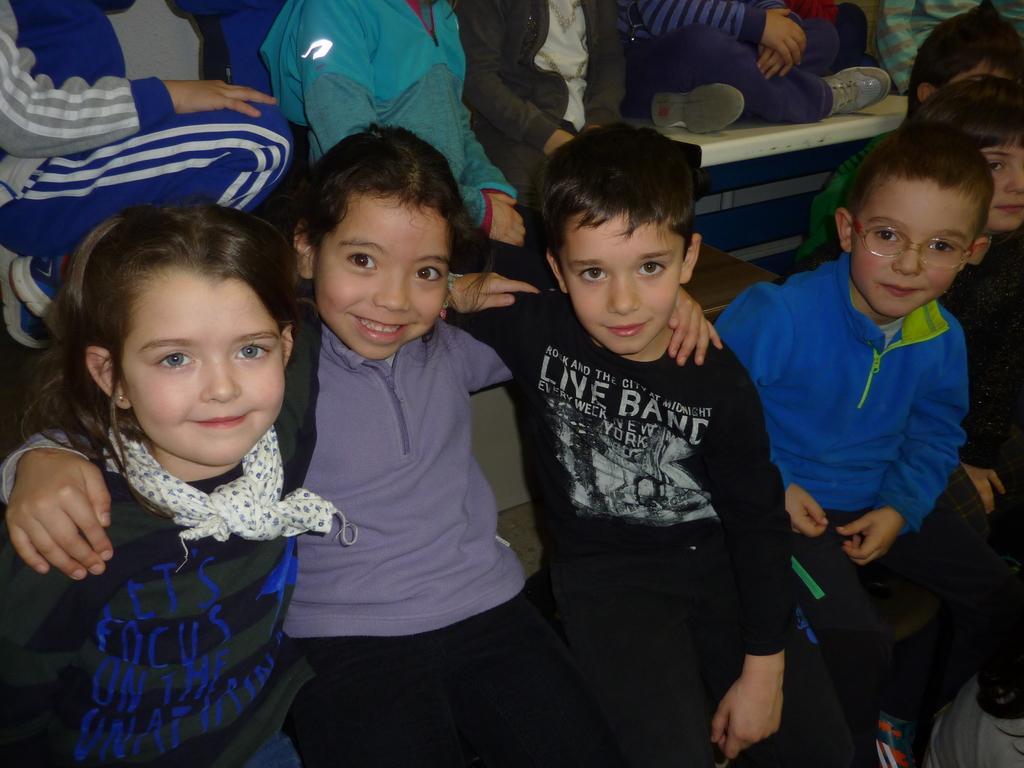Describe this image in one or two sentences. There are many children sitting. Boy on the right side is wearing a specs. Girl on the left side is wearing a scarf. 